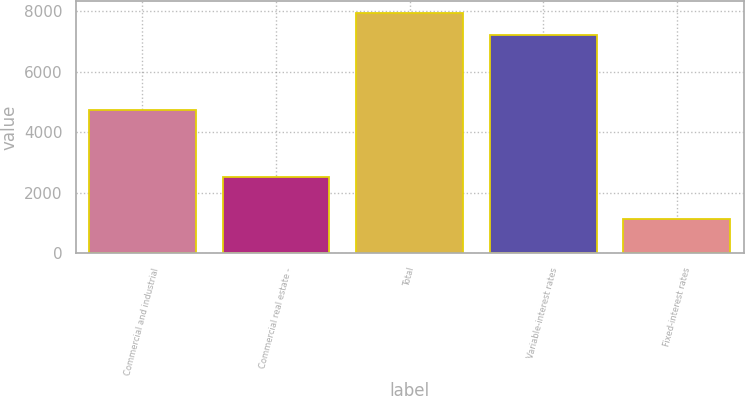<chart> <loc_0><loc_0><loc_500><loc_500><bar_chart><fcel>Commercial and industrial<fcel>Commercial real estate -<fcel>Total<fcel>Variable-interest rates<fcel>Fixed-interest rates<nl><fcel>4736<fcel>2510<fcel>7947.6<fcel>7223<fcel>1142.6<nl></chart> 